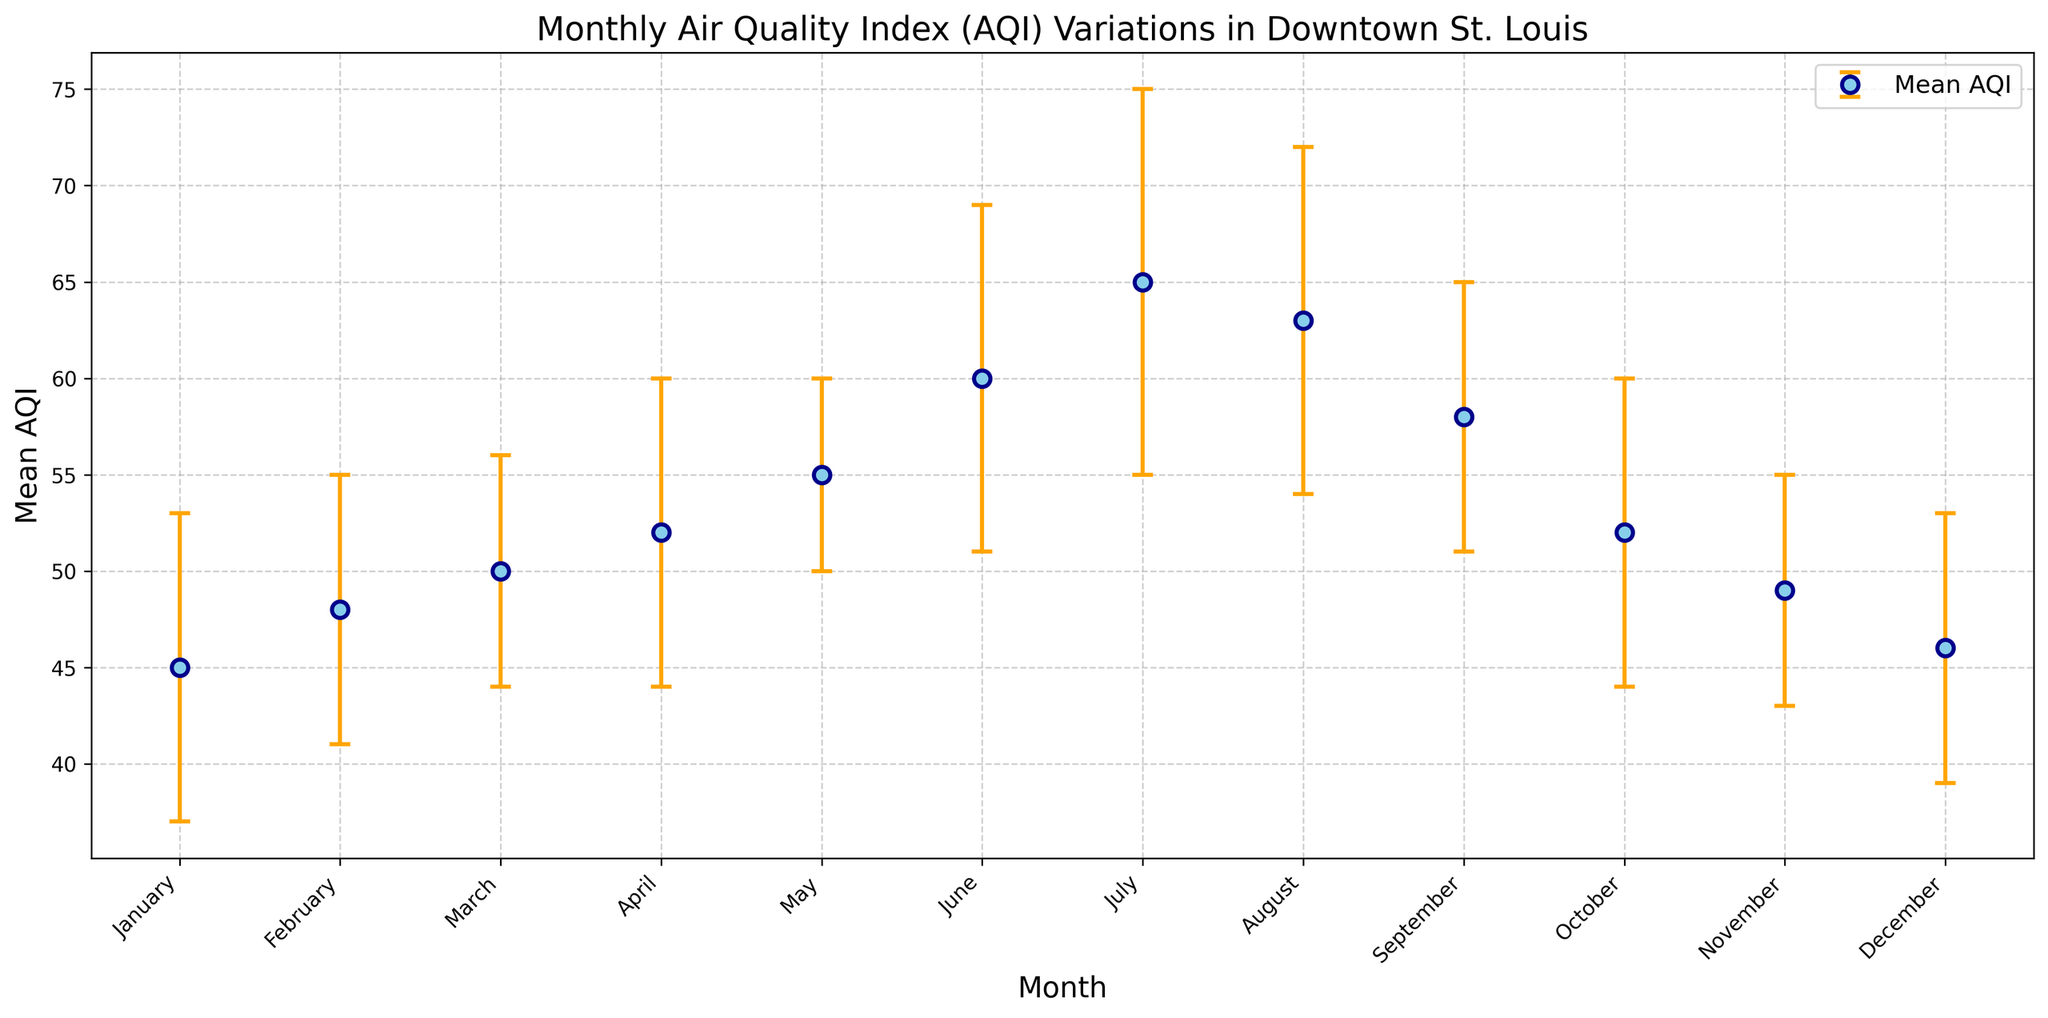What month experienced the highest mean AQI? Looking at the figure, July has the highest mean AQI. It's visibly higher than the AQIs of other months.
Answer: July Which month has the largest error bar? The error bar for July is the largest because it has both the highest mean AQI and the largest standard deviation, indicated by its relatively taller error bar compared to other months.
Answer: July How does the mean AQI for July compare to January? The mean AQI in July is 65, while in January, it's 45. To determine this, compare the height of the points representing both months on the graph. July's mean AQI is 20 units higher than January's mean AQI.
Answer: 20 units higher What's the average mean AQI for the first quarter (January to March)? To find the average mean AQI for January, February, and March, add their values (45+48+50) and divide by 3. (45 + 48 + 50) / 3 = 47.67
Answer: 47.67 Compare the trend of the mean AQI from January to December. The mean AQI starts at 45 in January, increases steadily to a peak of 65 in July, then gradually decreases to 46 in December. This trend shows a clear rise in the warmer months and a decline in the cooler months.
Answer: Rise in warmer months, decline in cooler months What months have mean AQIs within the range set by the error bars of March? The error bars for March indicate a range of 44-56 (mean ± standard deviation: 50 ± 6). Assessing other months that fall within this range (44-56), we find January, February, March, April, October, November, and December.
Answer: January, February, March, April, October, November, December Which month has a mean AQI closest to the overall yearly average? First, calculate the overall average AQI sum by adding all monthly mean AQIs: (45 + 48 + 50 + 52 + 55 + 60 + 65 + 63 + 58 + 52 + 49 + 46) / 12 = 54.5. The month of May, with a mean AQI of 55, is closest to this average.
Answer: May What is the range of mean AQIs for the entire year? Determine the range by finding the difference between the highest (July: 65) and lowest (January: 45) mean AQI values. Thus, the range is 65 - 45 = 20.
Answer: 20 Identify two consecutive months with the largest increase in mean AQI. Evaluate month-to-month mean AQI differences. The biggest jump is between June (60) and July (65), equating to a 5-unit increase.
Answer: June to July What is the median of the mean AQI values throughout the year? To find the median, list the mean AQIs in ascending order: 45, 46, 48, 49, 50, 52, 52, 55, 58, 60, 63, 65. The median is the average of the 6th and 7th values (52 and 52), which is (52+52)/2 = 52.
Answer: 52 